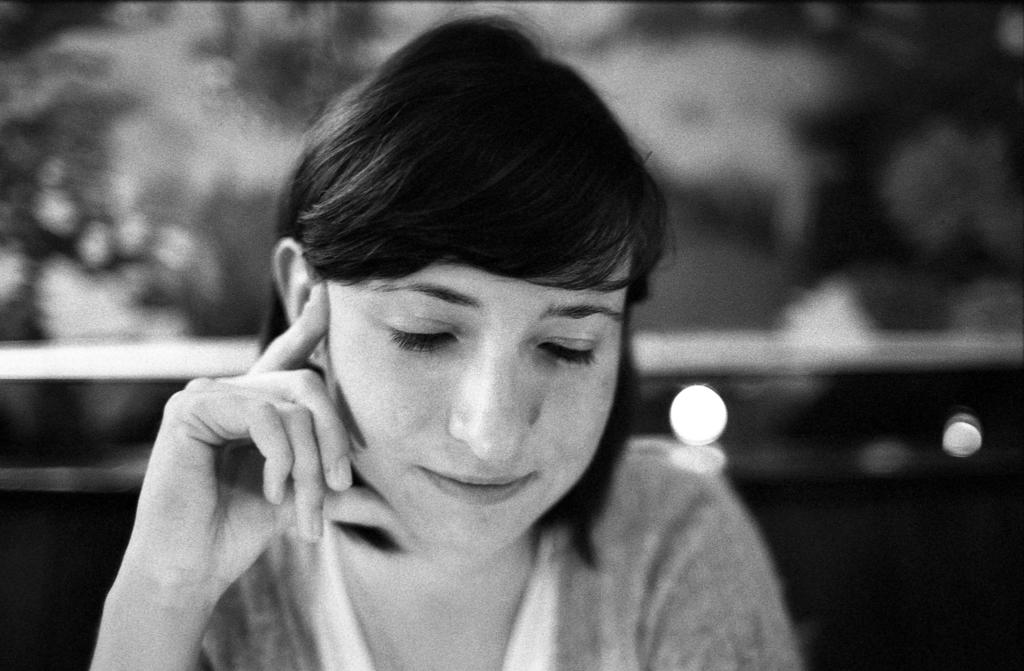What is the color scheme of the image? The image is black and white. Can you describe the main subject in the image? There is a woman in the image. What can be observed about the background of the image? The background of the image is blurred. How many girls are shaking a lamp in the image? There are no girls or lamps present in the image. 